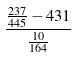<formula> <loc_0><loc_0><loc_500><loc_500>\frac { \frac { 2 3 7 } { 4 4 5 } - 4 3 1 } { \frac { 1 0 } { 1 6 4 } }</formula> 